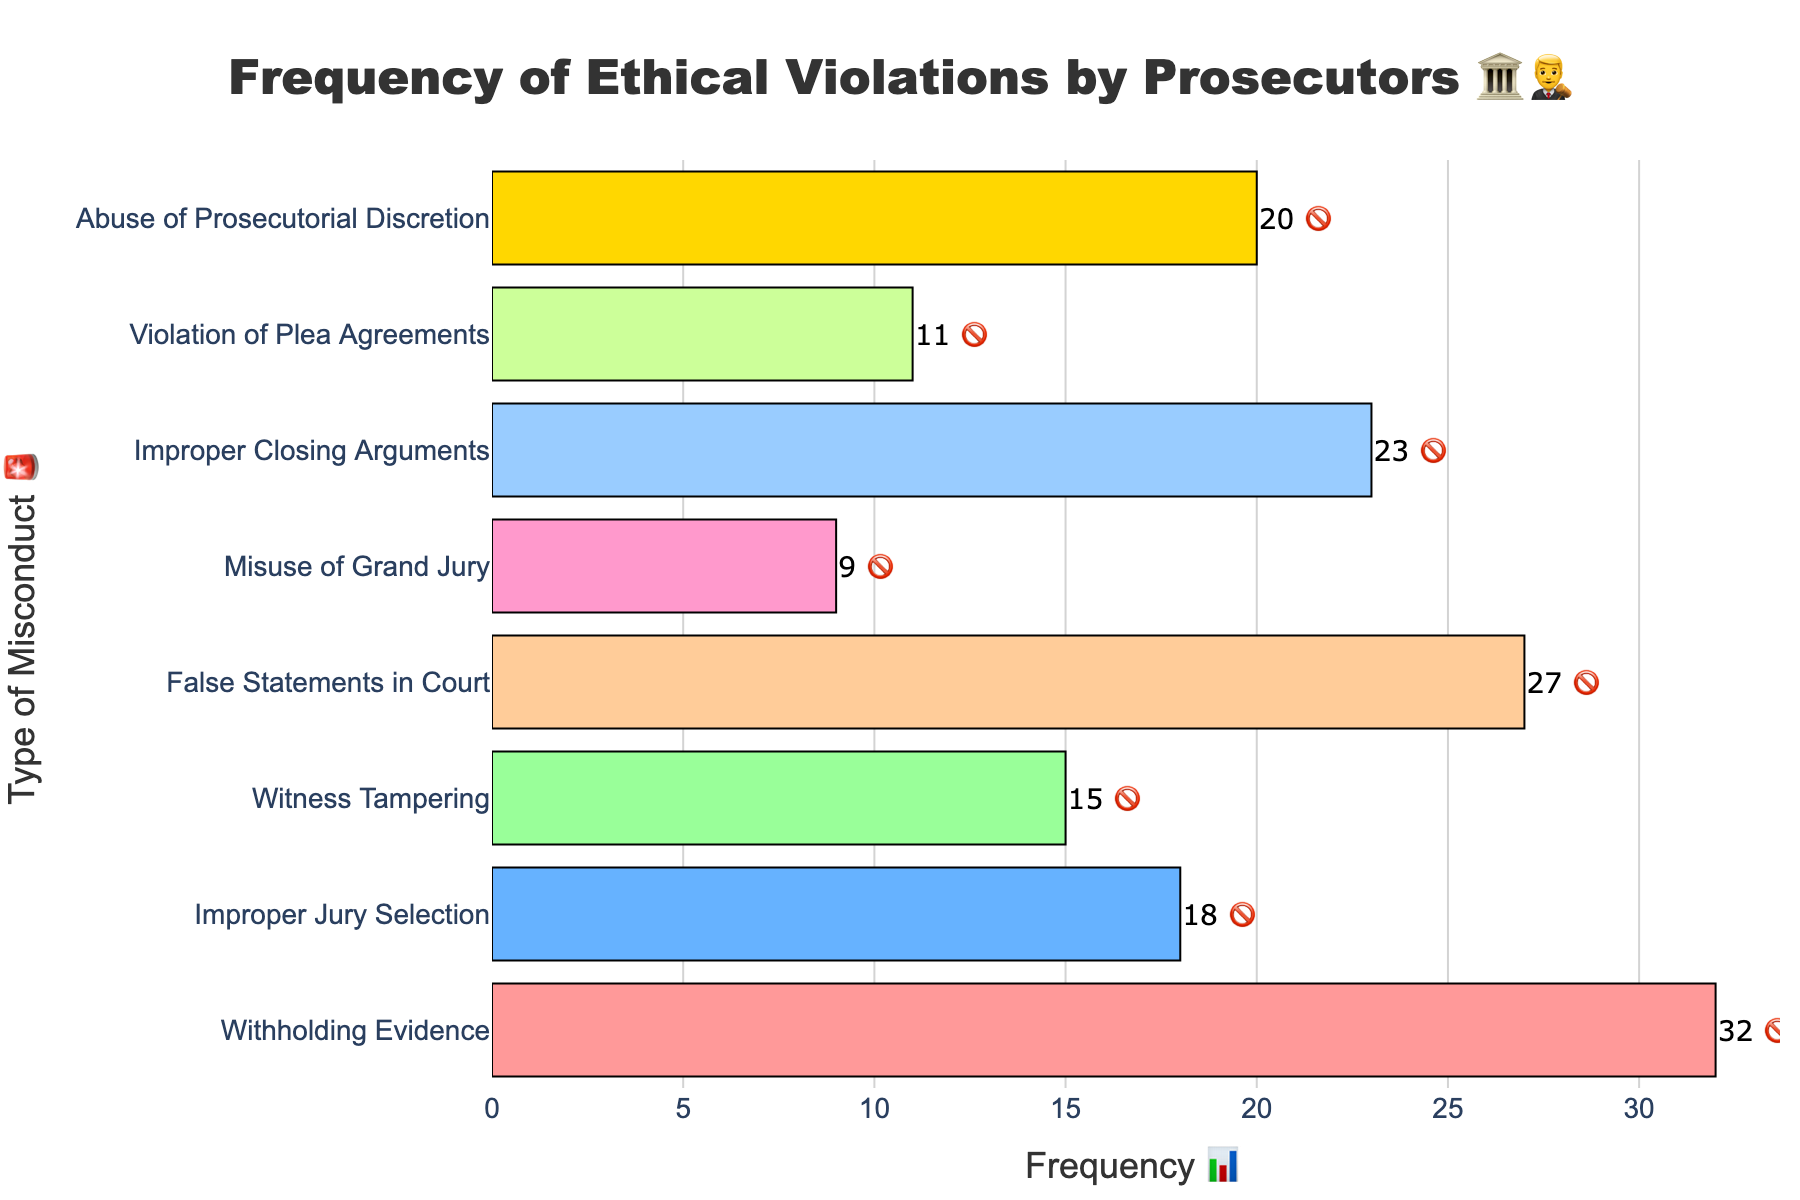what is the most common type of ethical violation by prosecutors? The figure shows a horizontal bar chart with frequencies for different types of ethical violations by prosecutors. The longest bar represents the highest frequency, which corresponds to "Withholding Evidence".
Answer: Withholding Evidence what is the frequency of False Statements in Court? In the chart, the bar labeled "False Statements in Court" has a frequency value displayed as text above it.
Answer: 27 which misconduct type has a frequency of 9? The chart labels each bar with the frequency value and the misconduct type. The bar with a frequency of 9 is labeled "Misuse of Grand Jury".
Answer: Misuse of Grand Jury how many types of misconduct have a frequency greater than 20? By inspecting the bars and their frequency labels, we identify the misconduct types with frequencies over 20: "Withholding Evidence," "False Statements in Court," and "Improper Closing Arguments." There are 3 such types.
Answer: 3 how frequent is Witness Tampering compared to Violation of Plea Agreements? From the chart, "Witness Tampering" has a frequency of 15, and "Violation of Plea Agreements" has a frequency of 11. Comparing these, Witness Tampering is more frequent.
Answer: more frequent what is the total frequency of ethical violations combining Improper Closing Arguments and Abuse of Prosecutorial Discretion? The frequencies for these misconduct types are 23 for Improper Closing Arguments and 20 for Abuse of Prosecutorial Discretion. Adding these together gives 23 + 20 = 43.
Answer: 43 which type of misconduct is represented with the emoji 🗣️? The figure lists types of misconduct with corresponding emojis. The emoji 🗣️ is associated with "Witness Tampering".
Answer: Witness Tampering are there more misconducts with frequency below 20 or above 20? Counting from the chart, misconducts below 20 include: "Improper Jury Selection", "Witness Tampering", "Misuse of Grand Jury", "Violation of Plea Agreements." Total = 4. Misconducts above 20 are: "Withholding Evidence", "False Statements in Court", "Improper Closing Arguments", "Abuse of Prosecutorial Discretion." Total = 4. There are equal numbers in both categories.
Answer: equal numbers 